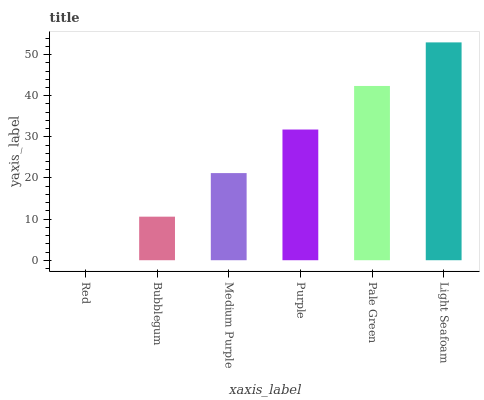Is Red the minimum?
Answer yes or no. Yes. Is Light Seafoam the maximum?
Answer yes or no. Yes. Is Bubblegum the minimum?
Answer yes or no. No. Is Bubblegum the maximum?
Answer yes or no. No. Is Bubblegum greater than Red?
Answer yes or no. Yes. Is Red less than Bubblegum?
Answer yes or no. Yes. Is Red greater than Bubblegum?
Answer yes or no. No. Is Bubblegum less than Red?
Answer yes or no. No. Is Purple the high median?
Answer yes or no. Yes. Is Medium Purple the low median?
Answer yes or no. Yes. Is Pale Green the high median?
Answer yes or no. No. Is Red the low median?
Answer yes or no. No. 